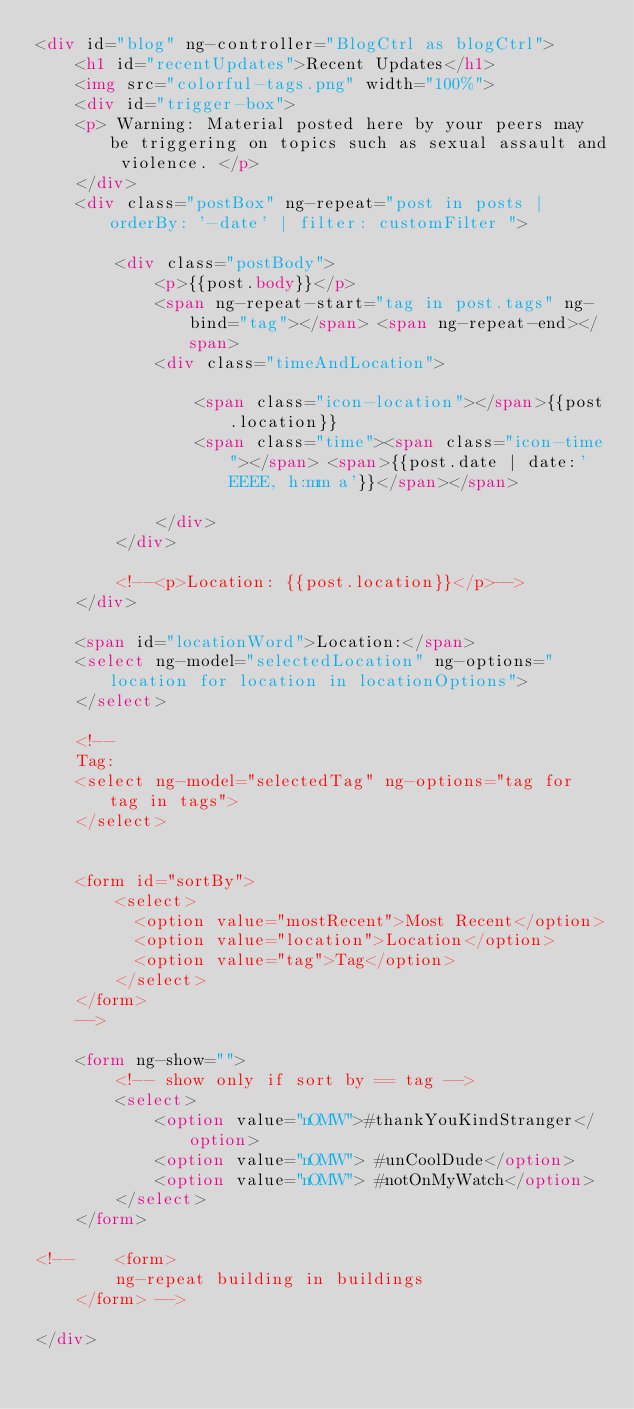<code> <loc_0><loc_0><loc_500><loc_500><_HTML_><div id="blog" ng-controller="BlogCtrl as blogCtrl">
	<h1 id="recentUpdates">Recent Updates</h1>
	<img src="colorful-tags.png" width="100%">
	<div id="trigger-box">
	<p> Warning: Material posted here by your peers may be triggering on topics such as sexual assault and violence. </p>
	</div>
	<div class="postBox" ng-repeat="post in posts | orderBy: '-date' | filter: customFilter ">
		
		<div class="postBody">
			<p>{{post.body}}</p>
            <span ng-repeat-start="tag in post.tags" ng-bind="tag"></span> <span ng-repeat-end></span>
            <div class="timeAndLocation">

				<span class="icon-location"></span>{{post.location}}
	 			<span class="time"><span class="icon-time"></span> <span>{{post.date | date:'EEEE, h:mm a'}}</span></span>

			</div>
        </div>

		<!--<p>Location: {{post.location}}</p>-->
	</div>

    <span id="locationWord">Location:</span>
    <select ng-model="selectedLocation" ng-options="location for location in locationOptions">
    </select>

    <!--
    Tag:
    <select ng-model="selectedTag" ng-options="tag for tag in tags">
    </select>


    <form id="sortBy">
		<select>
		  <option value="mostRecent">Most Recent</option>
		  <option value="location">Location</option>
		  <option value="tag">Tag</option>
		</select>
	</form>
	-->

	<form ng-show="">
		<!-- show only if sort by == tag -->
		<select>
			<option value="nOMW">#thankYouKindStranger</option>
			<option value="nOMW"> #unCoolDude</option>
			<option value="nOMW"> #notOnMyWatch</option>
		</select>
	</form>

<!-- 	<form>
		ng-repeat building in buildings
	</form> -->

</div>
</code> 